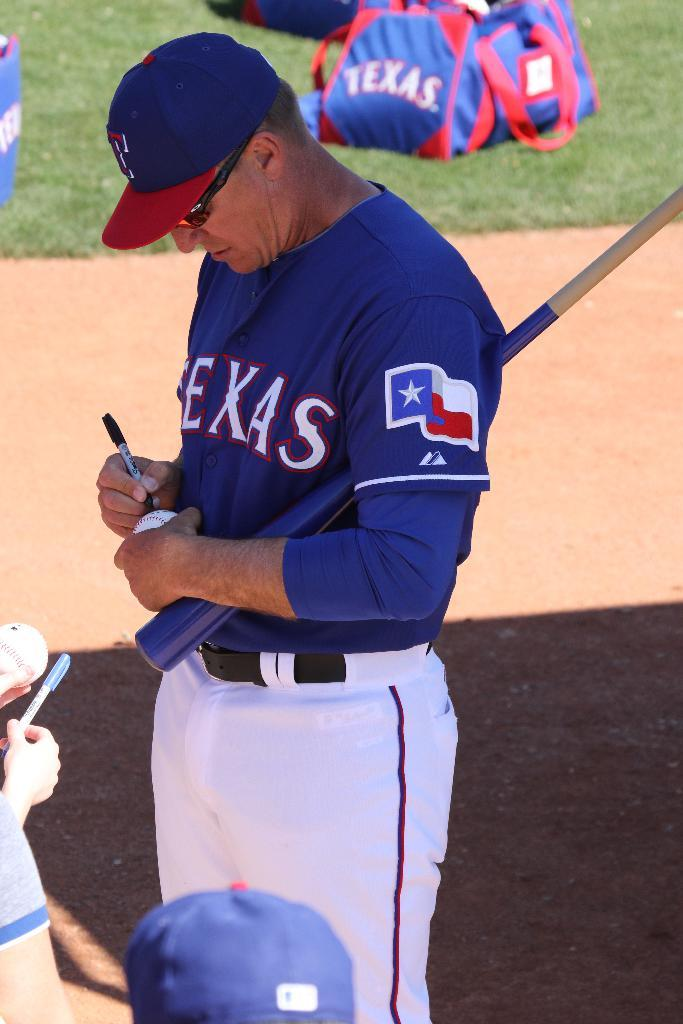Provide a one-sentence caption for the provided image. A baseball player wearing a blue jersey that says Texans across the front signing a baseball. 